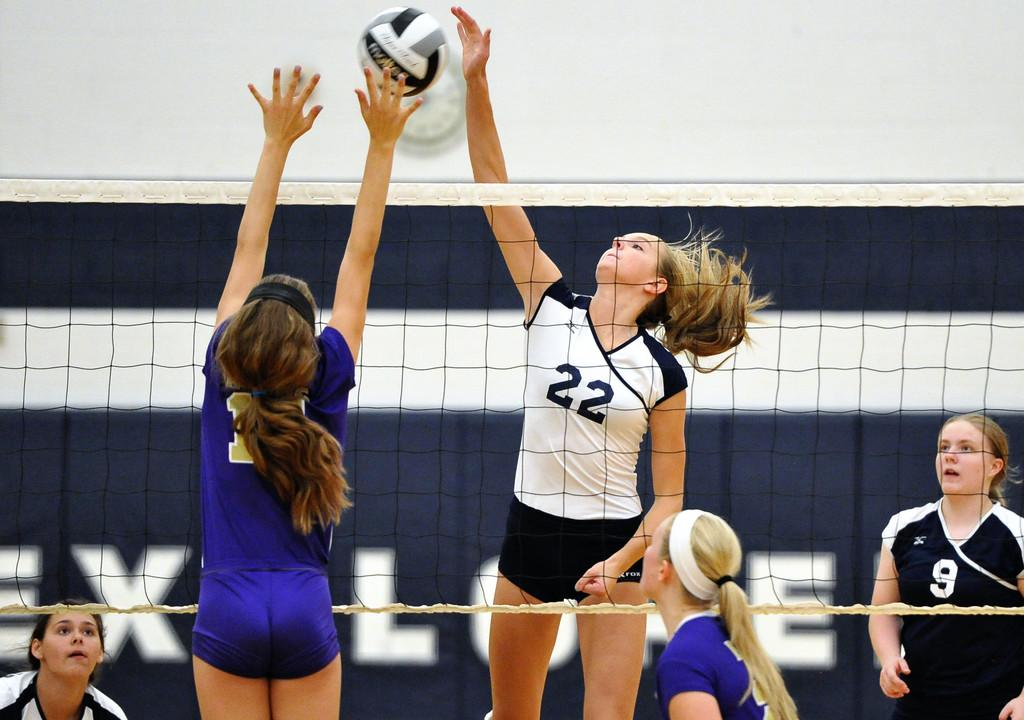<image>
Give a short and clear explanation of the subsequent image. some players playing a game with one wearing 22 on them 